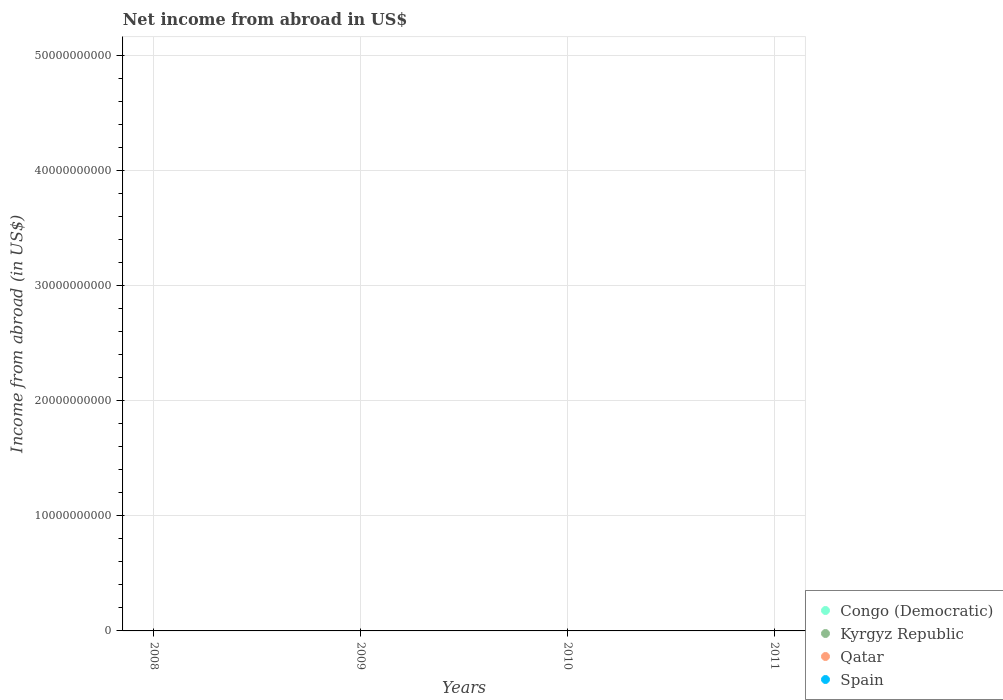How many different coloured dotlines are there?
Ensure brevity in your answer.  0. What is the net income from abroad in Kyrgyz Republic in 2009?
Offer a terse response. 0. Across all years, what is the minimum net income from abroad in Spain?
Keep it short and to the point. 0. What is the total net income from abroad in Qatar in the graph?
Give a very brief answer. 0. What is the difference between the net income from abroad in Congo (Democratic) in 2008 and the net income from abroad in Kyrgyz Republic in 2009?
Ensure brevity in your answer.  0. In how many years, is the net income from abroad in Congo (Democratic) greater than 2000000000 US$?
Offer a terse response. 0. Is it the case that in every year, the sum of the net income from abroad in Congo (Democratic) and net income from abroad in Qatar  is greater than the net income from abroad in Kyrgyz Republic?
Offer a very short reply. No. Is the net income from abroad in Congo (Democratic) strictly greater than the net income from abroad in Spain over the years?
Keep it short and to the point. No. Is the net income from abroad in Qatar strictly less than the net income from abroad in Congo (Democratic) over the years?
Provide a short and direct response. No. How many dotlines are there?
Provide a succinct answer. 0. What is the difference between two consecutive major ticks on the Y-axis?
Your response must be concise. 1.00e+1. Are the values on the major ticks of Y-axis written in scientific E-notation?
Ensure brevity in your answer.  No. Does the graph contain any zero values?
Make the answer very short. Yes. How many legend labels are there?
Provide a succinct answer. 4. How are the legend labels stacked?
Offer a very short reply. Vertical. What is the title of the graph?
Your answer should be very brief. Net income from abroad in US$. Does "Vanuatu" appear as one of the legend labels in the graph?
Ensure brevity in your answer.  No. What is the label or title of the X-axis?
Offer a very short reply. Years. What is the label or title of the Y-axis?
Your response must be concise. Income from abroad (in US$). What is the Income from abroad (in US$) of Congo (Democratic) in 2008?
Your response must be concise. 0. What is the Income from abroad (in US$) in Congo (Democratic) in 2009?
Provide a short and direct response. 0. What is the Income from abroad (in US$) of Qatar in 2009?
Give a very brief answer. 0. What is the Income from abroad (in US$) in Spain in 2009?
Provide a short and direct response. 0. What is the Income from abroad (in US$) in Congo (Democratic) in 2010?
Give a very brief answer. 0. What is the Income from abroad (in US$) in Kyrgyz Republic in 2010?
Offer a terse response. 0. What is the Income from abroad (in US$) of Spain in 2010?
Your answer should be compact. 0. What is the Income from abroad (in US$) in Congo (Democratic) in 2011?
Provide a succinct answer. 0. What is the total Income from abroad (in US$) in Qatar in the graph?
Give a very brief answer. 0. What is the average Income from abroad (in US$) of Qatar per year?
Make the answer very short. 0. What is the average Income from abroad (in US$) in Spain per year?
Offer a terse response. 0. 